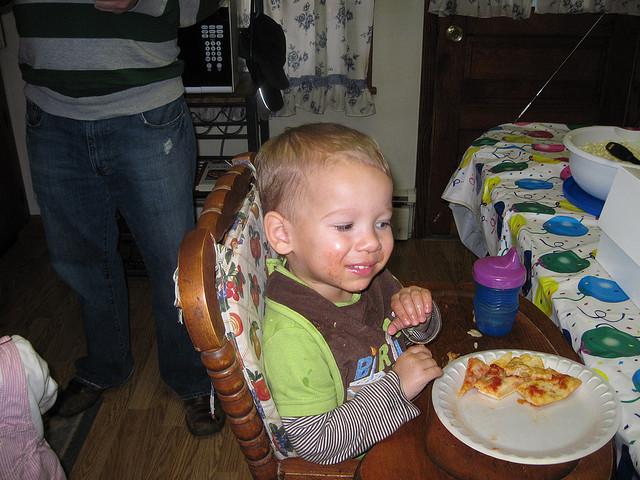Is that baby a boy?
Answer briefly. Yes. What special day is it for this boy?
Quick response, please. Birthday. Did the boy make a mess?
Write a very short answer. Yes. Why are there balloons on the tablecloth?
Keep it brief. Birthday. What color is the child's chair?
Give a very brief answer. Brown. 